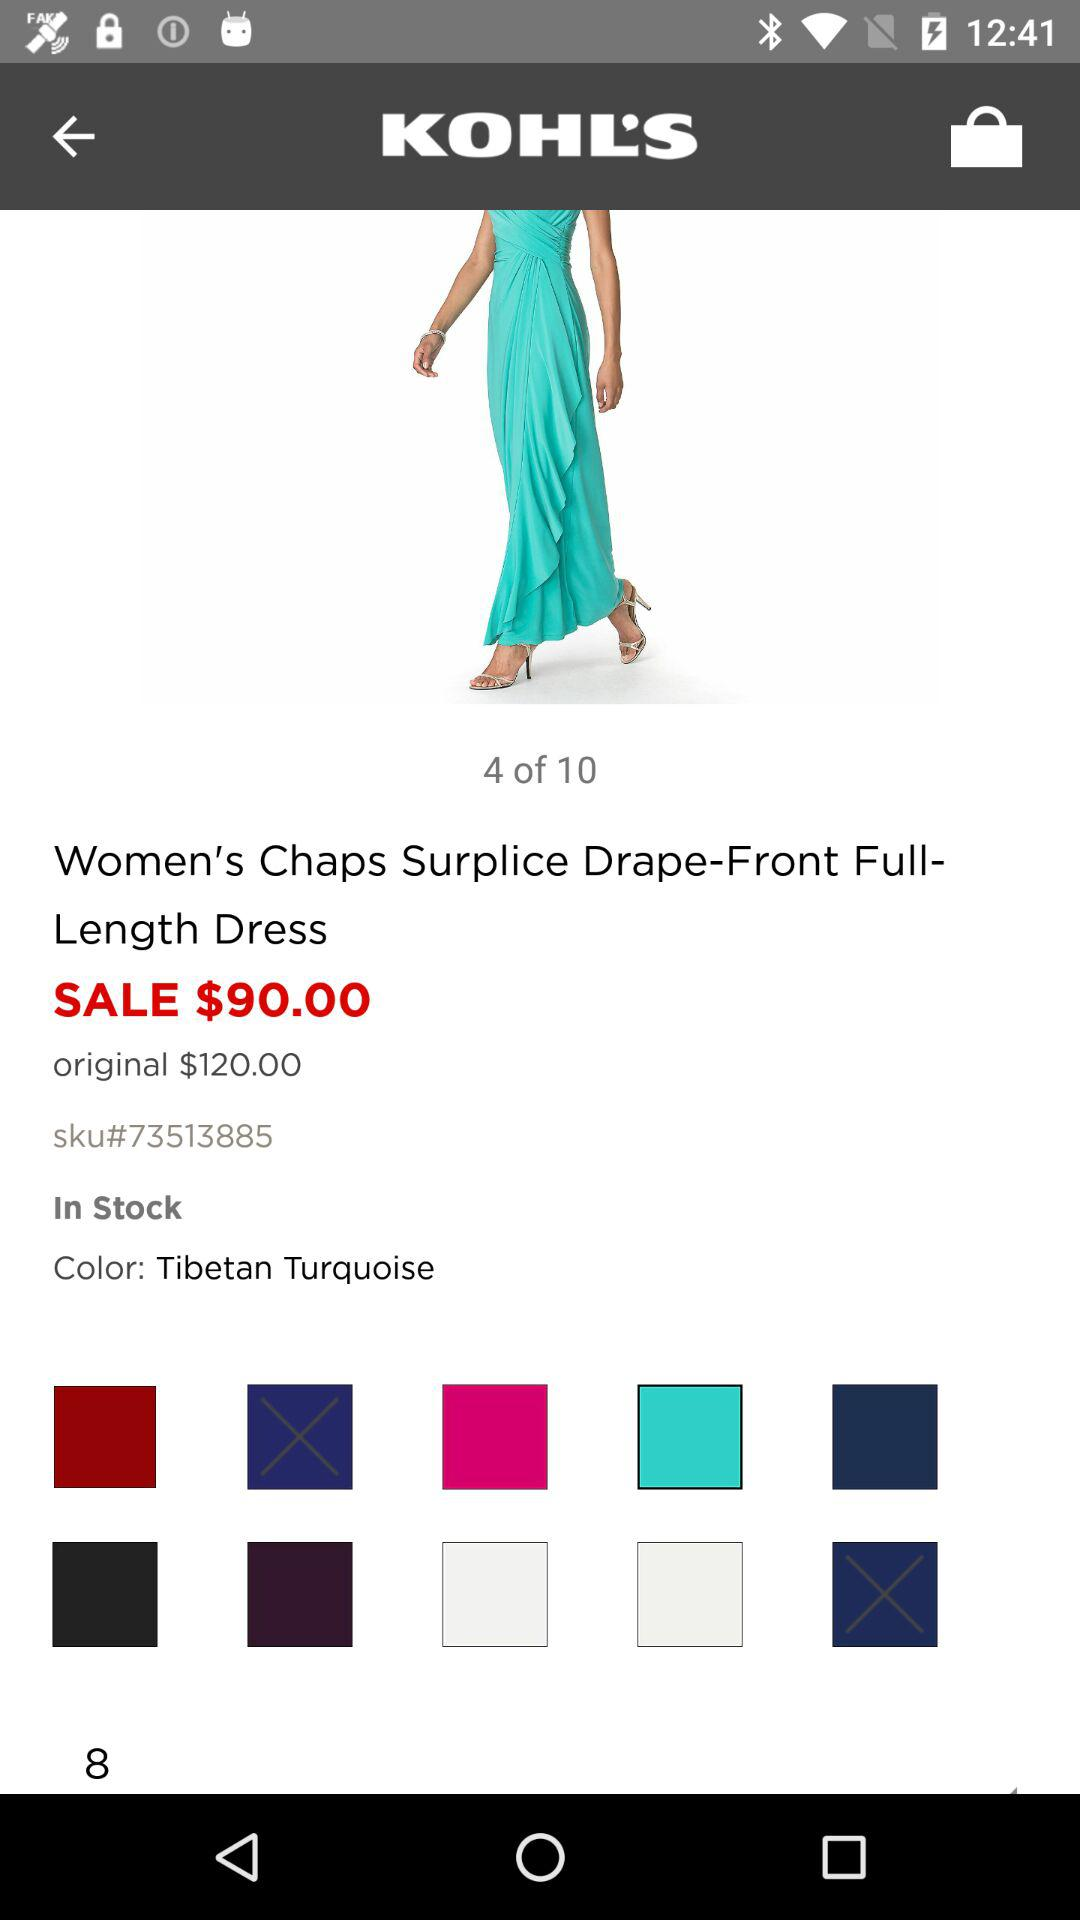What is the name of the color of the dress?
Answer the question using a single word or phrase. Tibetan Turquoise 